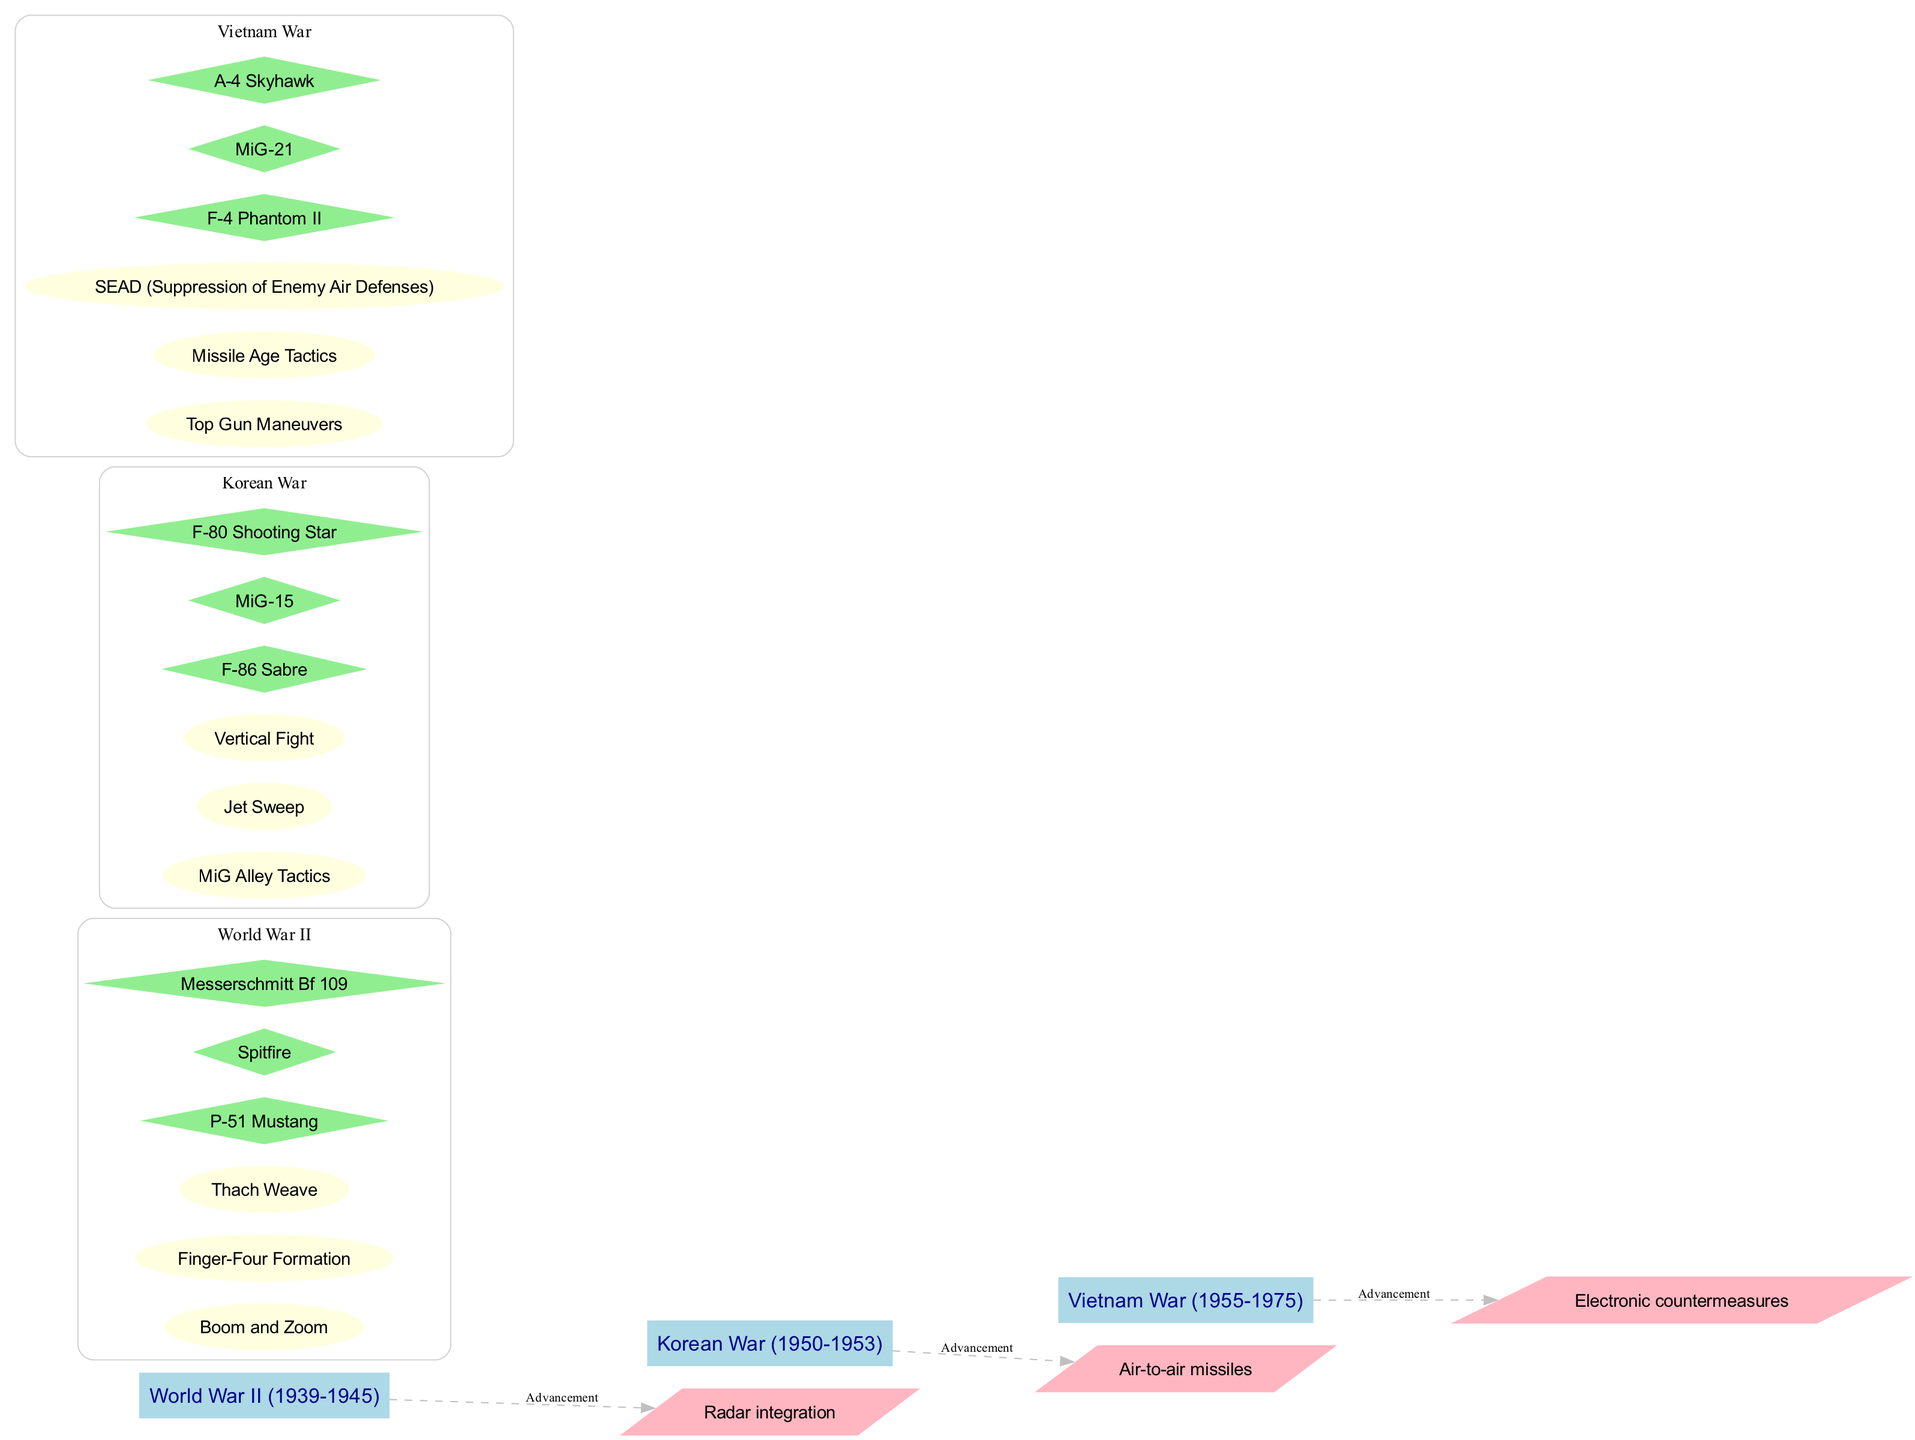What are the three main air combat tactics used in World War II? According to the diagram, the three main air combat tactics listed under World War II are "Boom and Zoom," "Finger-Four Formation," and "Thach Weave."
Answer: Boom and Zoom, Finger-Four Formation, Thach Weave How many key aircraft are associated with the Korean War? The diagram shows three key aircraft associated with the Korean War, which are the F-86 Sabre, MiG-15, and F-80 Shooting Star.
Answer: 3 Which tactic is associated with the Vietnam War that involves electronic warfare? The tactic associated with the Vietnam War involving electronic warfare is "SEAD" which stands for Suppression of Enemy Air Defenses.
Answer: SEAD What is the relationship between technological advancements and World War II in the diagram? The diagram indicates that there is an edge labeled "Advancement" from the World War II era to the technological advancement "Radar integration," illustrating that this technology was relevant during that era.
Answer: Radar integration Which air combat tactic transitioned from World War II to the Korean War, emphasizing vertical maneuvers? The "Vertical Fight" tactic in the Korean War represents a transition towards a focus on vertical maneuvers, evolving from the tactics used in World War II.
Answer: Vertical Fight What is the color of the tactics nodes for the Korean War? The nodes for the tactics associated with the Korean War are colored light yellow according to the diagram’s color-coding scheme for tactics.
Answer: Light yellow How many technological advancements are displayed in the diagram? The diagram shows three technological advancements, which include radar integration, air-to-air missiles, and electronic countermeasures.
Answer: 3 Name one key air combat tactic from the Vietnam War. One key air combat tactic from the Vietnam War shown in the diagram is "Top Gun Maneuvers."
Answer: Top Gun Maneuvers 